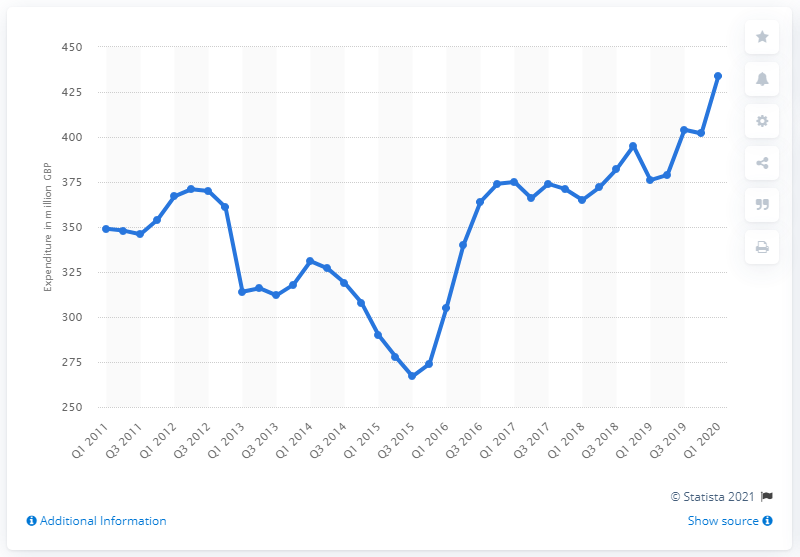Indicate a few pertinent items in this graphic. The total expenditure on bicycles in the UK in the first quarter of 2020 was 434. 